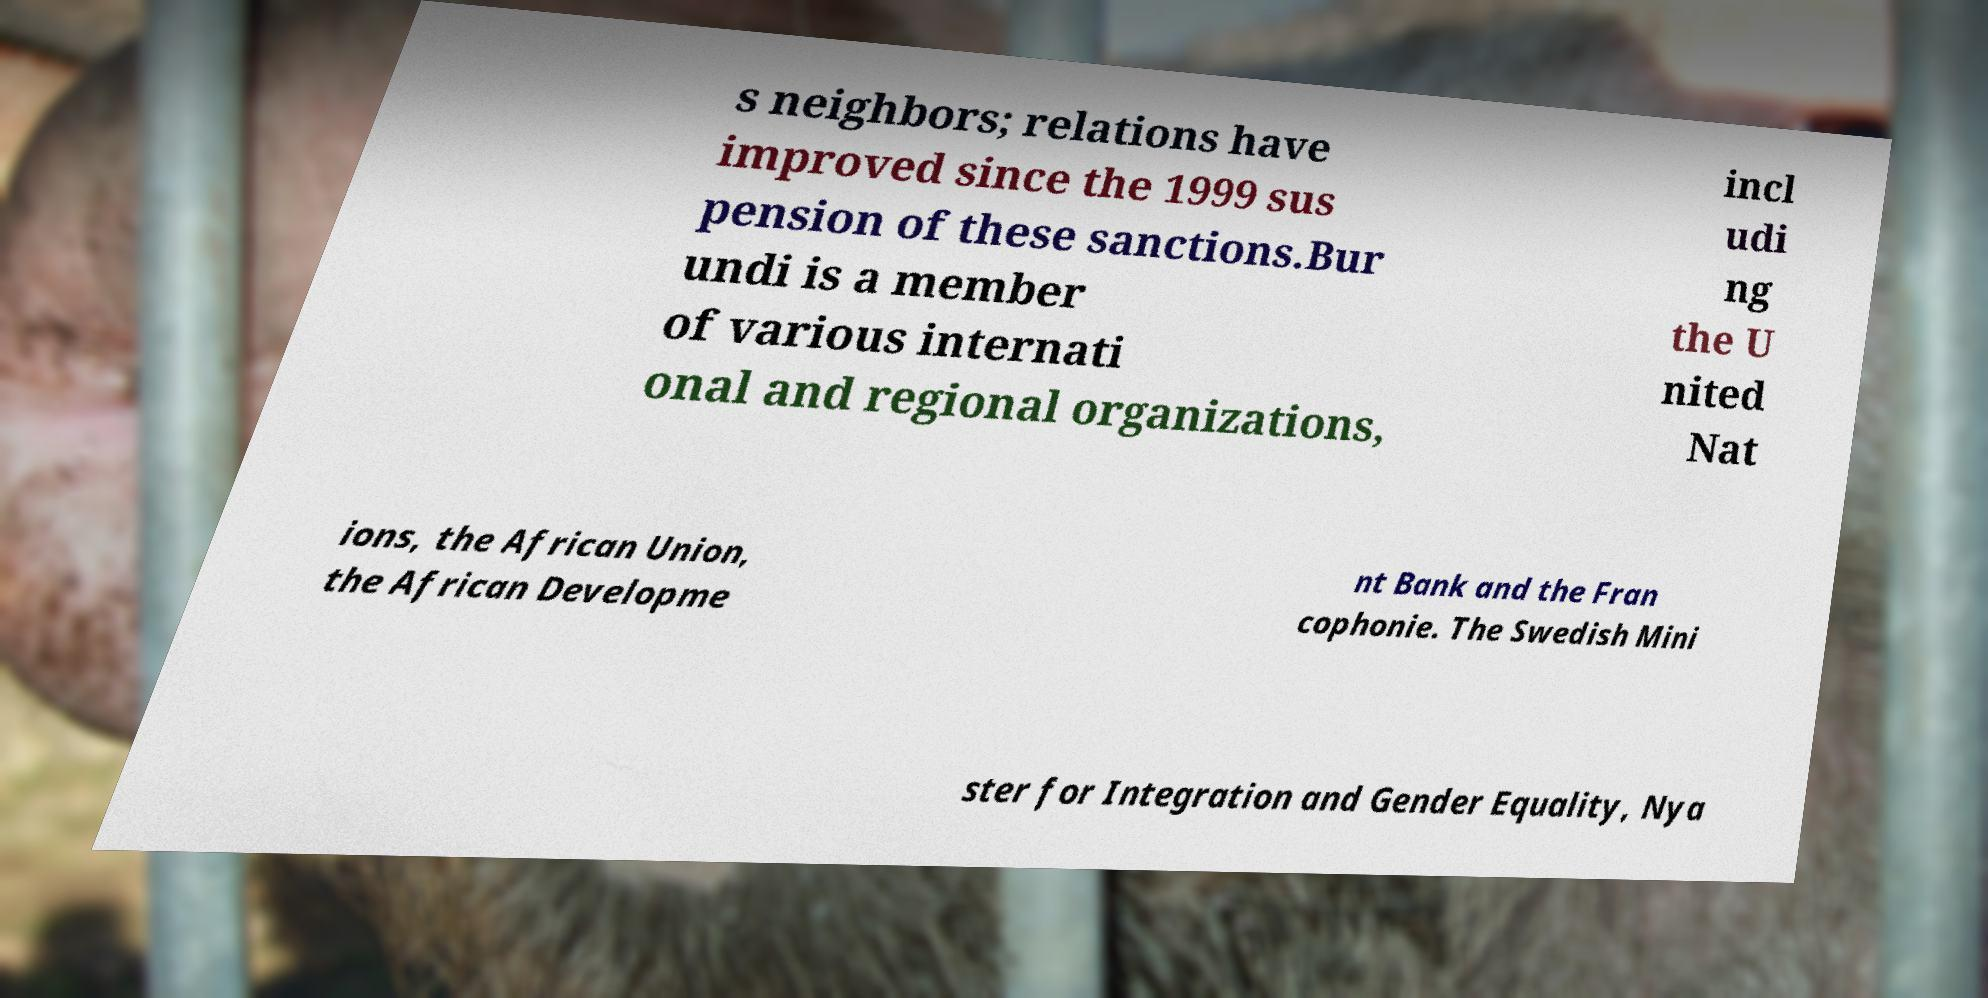Please read and relay the text visible in this image. What does it say? s neighbors; relations have improved since the 1999 sus pension of these sanctions.Bur undi is a member of various internati onal and regional organizations, incl udi ng the U nited Nat ions, the African Union, the African Developme nt Bank and the Fran cophonie. The Swedish Mini ster for Integration and Gender Equality, Nya 